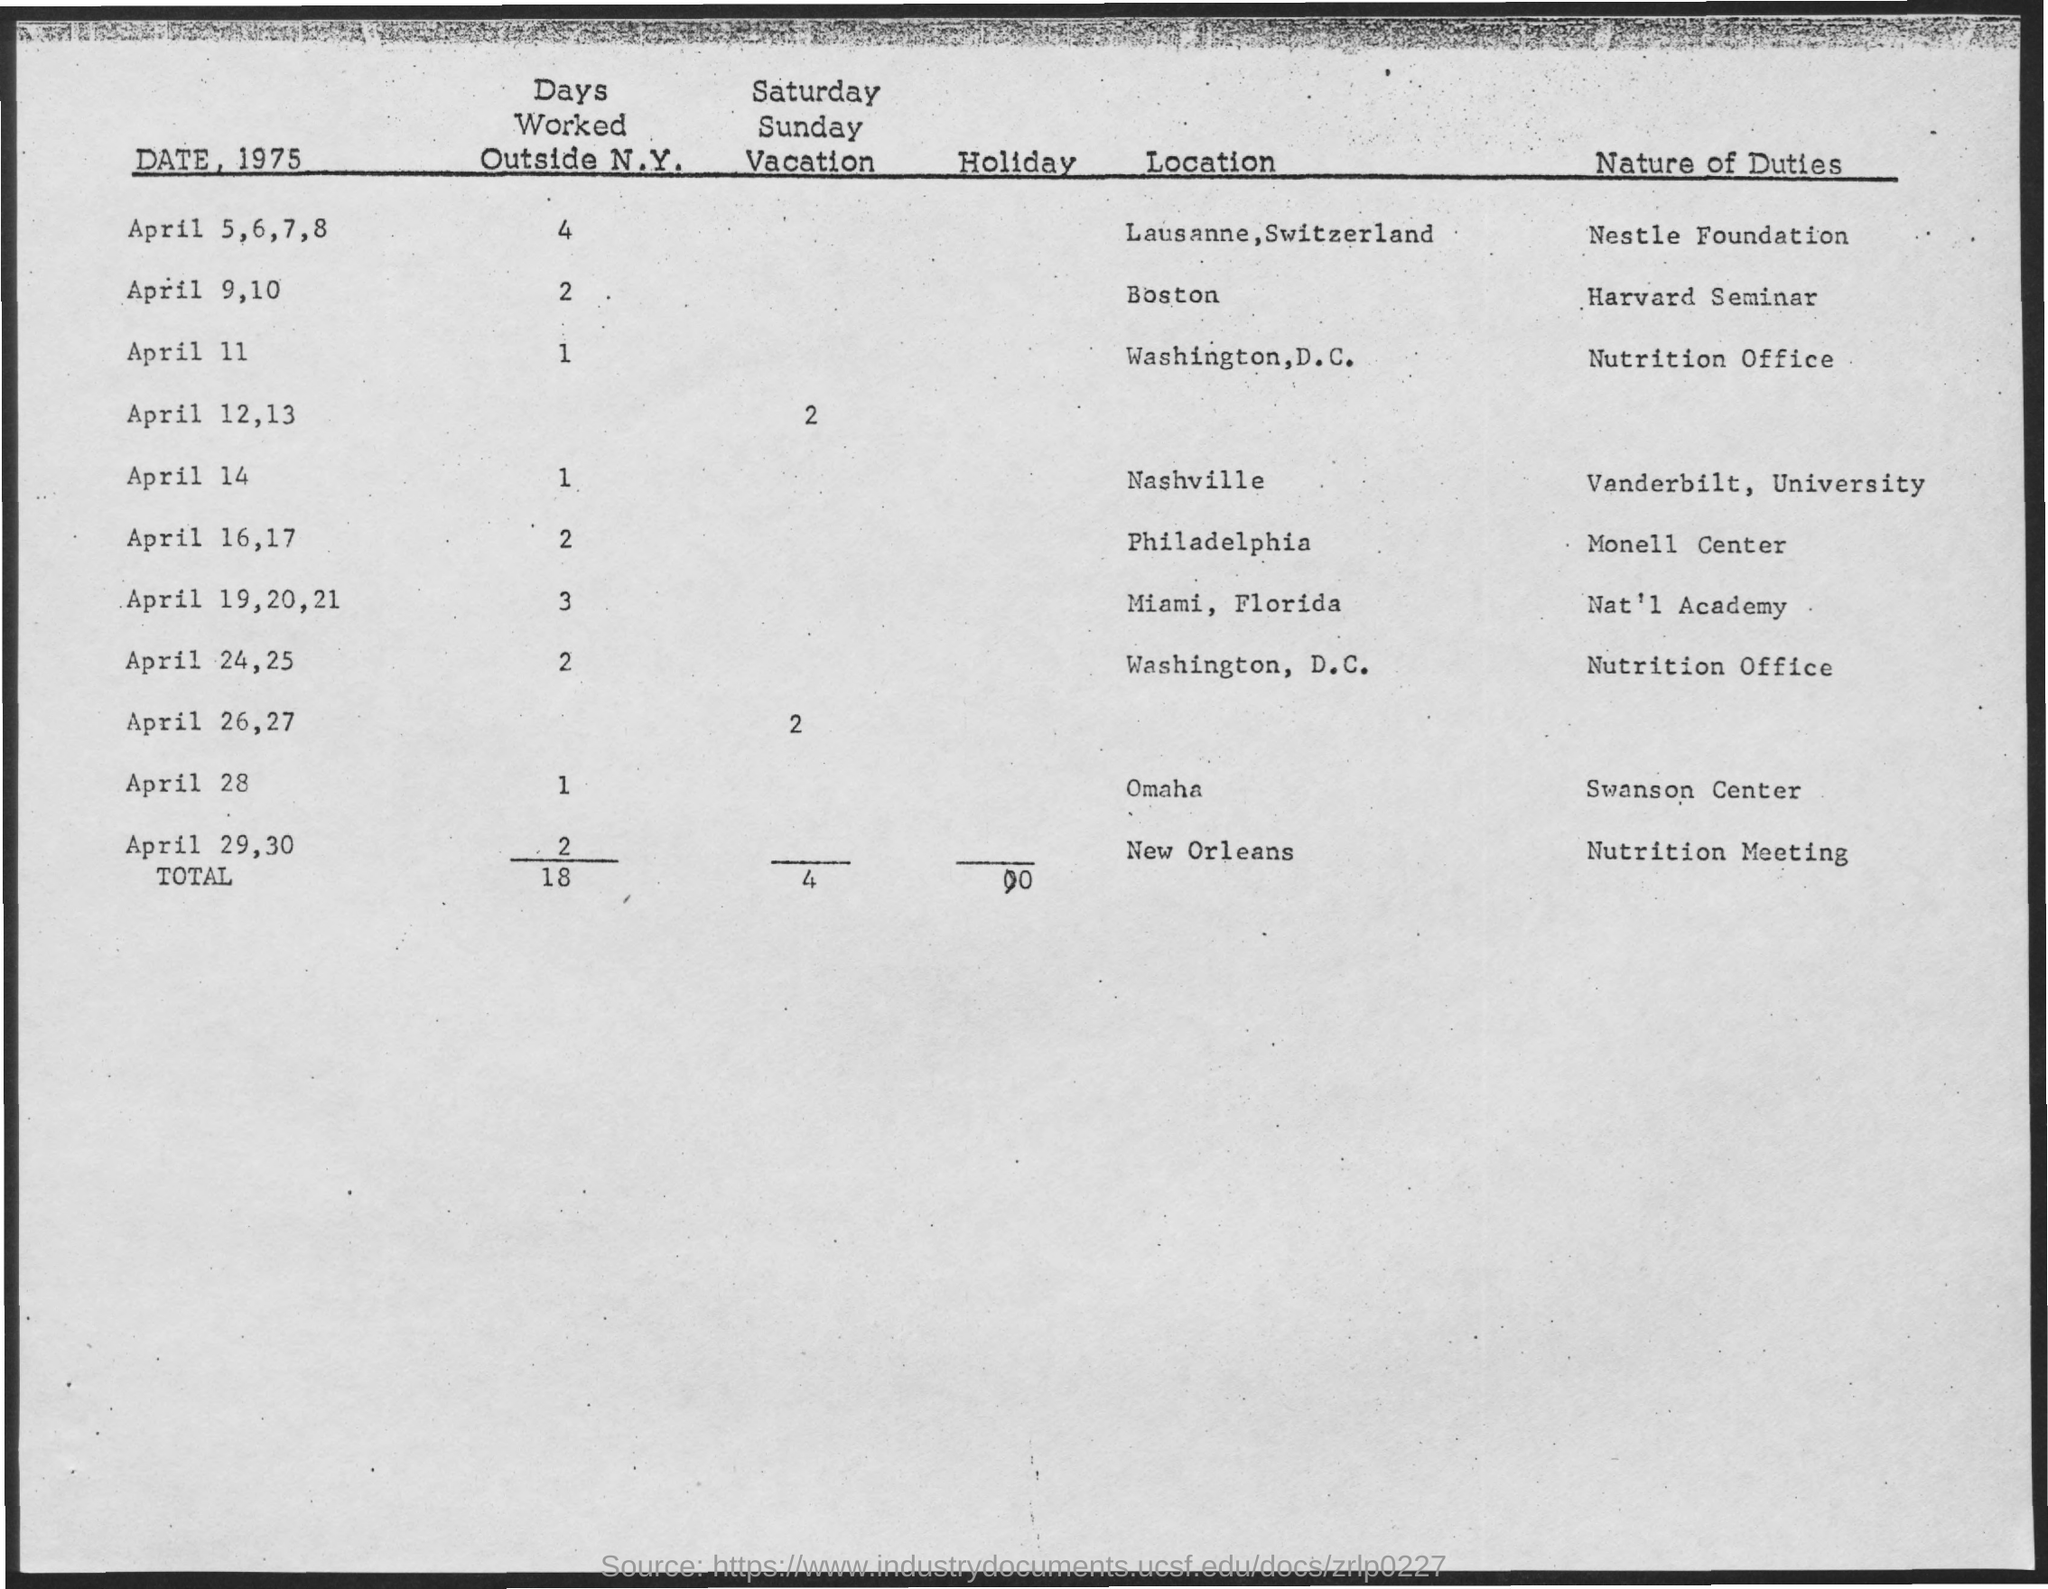What is the total number of days worked outside N.Y.?
Your response must be concise. 18. What is the nature of duty on April 11?
Make the answer very short. Nutrition office. What is the nature of duty on April 28?
Your response must be concise. Swanson Center. What is the number of days worked outside N.Y. on April 11?
Your response must be concise. 1. What is the number of Saturday-Sunday vacations on April 26,27?
Your answer should be very brief. 2. What is the total number of Saturday, Sunday vacations?
Make the answer very short. 4. 